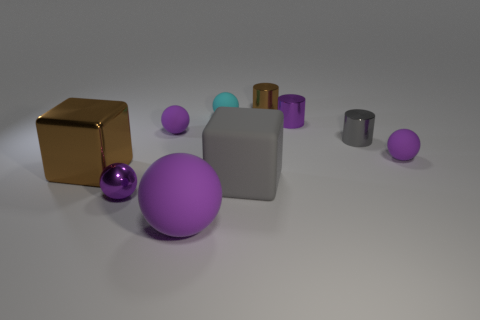The large matte sphere is what color?
Make the answer very short. Purple. There is a matte thing that is the same shape as the big metal thing; what color is it?
Your response must be concise. Gray. How many other cyan matte objects are the same shape as the small cyan matte thing?
Keep it short and to the point. 0. How many things are either large blue shiny cylinders or gray objects in front of the big brown object?
Keep it short and to the point. 1. Is the color of the big shiny thing the same as the rubber object that is to the right of the tiny purple metal cylinder?
Make the answer very short. No. What is the size of the shiny object that is both on the left side of the large purple rubber sphere and behind the rubber block?
Keep it short and to the point. Large. Are there any gray things in front of the large purple rubber thing?
Ensure brevity in your answer.  No. There is a tiny metallic cylinder behind the cyan ball; is there a ball that is right of it?
Your answer should be compact. Yes. Are there the same number of matte objects left of the large purple sphere and brown things in front of the brown block?
Your answer should be very brief. No. There is a big object that is the same material as the big gray cube; what color is it?
Make the answer very short. Purple. 